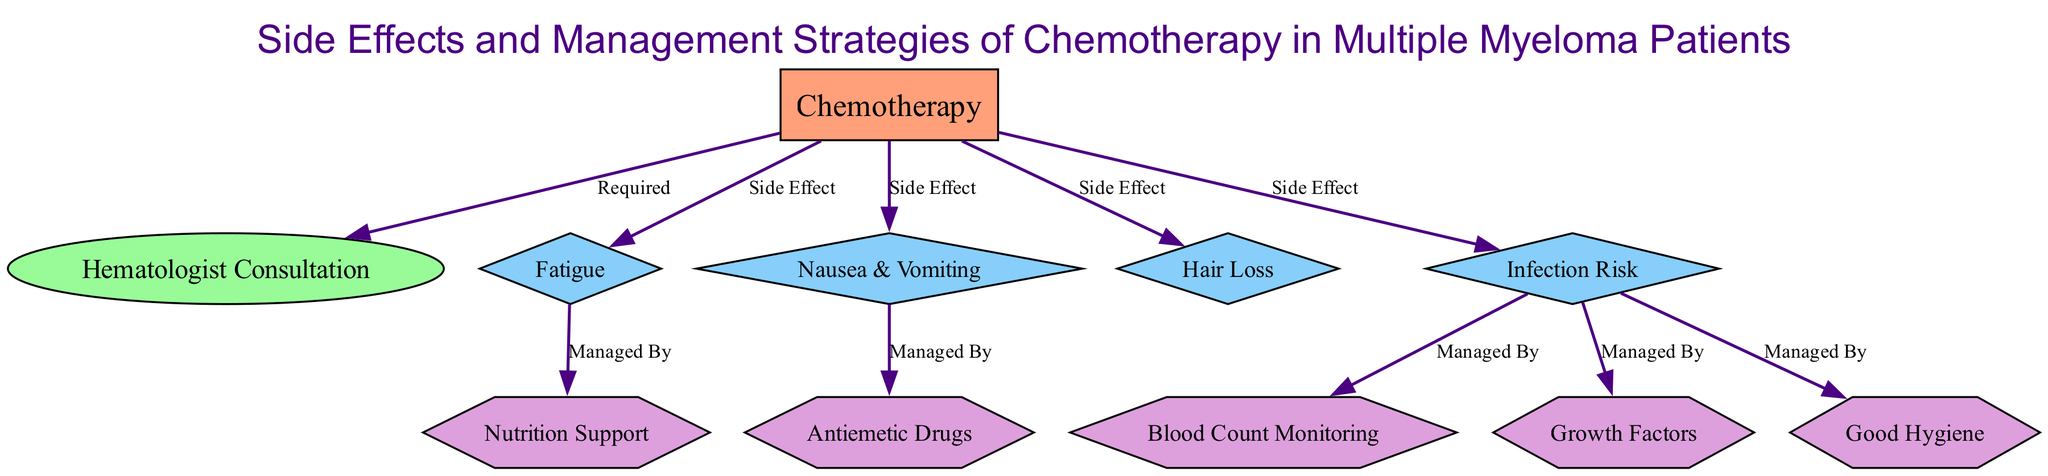What is the central topic of the diagram? The central topic is identified in the diagram as "Chemotherapy" which is at the center of the structure.
Answer: Chemotherapy How many side effects of chemotherapy are listed in the diagram? The diagram lists four side effects: Fatigue, Nausea & Vomiting, Hair Loss, and Infection Risk. Counting these gives a total of four.
Answer: 4 What management strategy is linked to the side effect of Fatigue? The diagram shows that Fatigue is managed by "Nutrition Support." This connection is directly indicated in the edges of the diagram.
Answer: Nutrition Support Which side effect requires the management strategies of Good Hygiene, Growth Factors, and Blood Count Monitoring? The side effect that connects to these management strategies is "Infection Risk." The diagram explicitly illustrates these relationships.
Answer: Infection Risk What type of node is "Anti-nausea Drugs"? "Anti-nausea Drugs" is categorized as a management strategy in the diagram, reflected by its hexagonal shape.
Answer: Management Strategy How many edges stem from the chemotherapy node? The chemotherapy node is connected to four nodes representing side effects, meaning there are four edges stemming from it. This is counted by looking at the connections from the central node.
Answer: 4 What is required following chemotherapy according to the diagram? The diagram indicates "Hematologist Consultation" is required after chemotherapy, signifying the necessary follow-up interaction.
Answer: Hematologist Consultation Which side effect is specifically described by the need for antiemetic drugs? The side effect relevant to the need for antiemetic drugs is "Nausea & Vomiting," as represented in the edges of the diagram.
Answer: Nausea & Vomiting What relationship does the "Hematologist Consultation" have with chemotherapy? The relationship is that it is a "Required" process following chemotherapy, clearly indicated by the edge connecting both nodes.
Answer: Required 